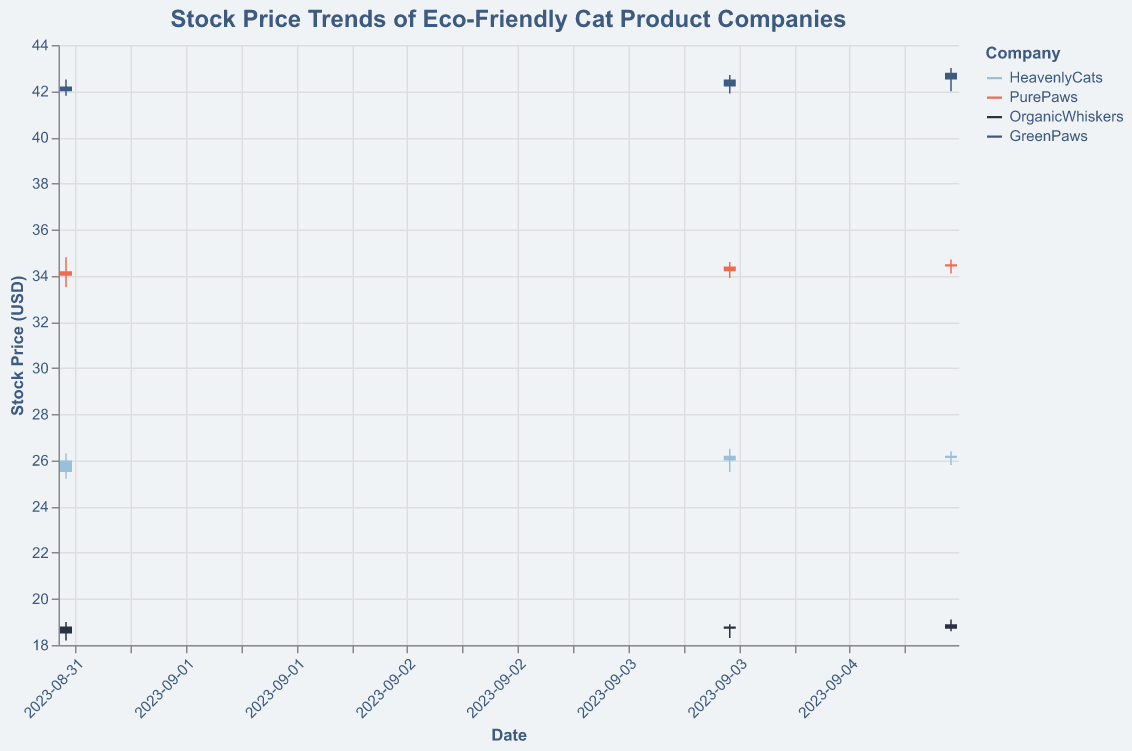What's the title of the figure? The title is usually located at the top of the figure and provides an overview of what the figure is about.
Answer: Stock Price Trends of Eco-Friendly Cat Product Companies What is the color used for the "PurePaws" company in the figure? Color is used to distinguish different companies in the figure. We can see from the legend that "PurePaws" is marked with a particular color.
Answer: Orange How many days of data are represented for each company? The x-axis shows the dates for which the data is available. By counting the distinct dates in the data for each company, we can determine the number of days.
Answer: 3 Which company had the highest stock price within the given dates, and what was it? To find the highest stock price, we need to compare the 'High' prices of all companies shown in the figure. The company with the highest 'High' value is the one we need.
Answer: GreenPaws, 43.00 On which day did "OrganicWhiskers" have the lowest closing price, and what was the price? We need to look at the 'Close' prices for all dates for "OrganicWhiskers" and identify the date with the minimum value.
Answer: September 4, 18.70 Which company had the highest trading volume on any given day, and what was the volume? The volume is plotted for each trading day. We need to locate the day that had the maximum 'Volume' across all companies.
Answer: PurePaws, 710,000 Between "HeavenlyCats" and "GreenPaws", which company had greater stock price volatility on September 5, and how is volatility calculated? Volatility can be determined by the range between 'High' and 'Low' prices. Calculate the range for each company on September 5 and compare them.
Answer: GreenPaws, 1.00 (range is 43.00 - 42.00) Which company showed a continuous increase in 'Close' prices over the three days? We need to examine the 'Close' prices of each company for trends and identify if any company had an increasing trend over the given dates.
Answer: PurePaws What is the average closing price for "HeavenlyCats" over the shown dates? To compute the average closing price, sum up the 'Close' values for the given dates and divide by the number of days. (26.00 + 26.20 + 26.10)/ 3 = 26.10
Answer: 26.10 